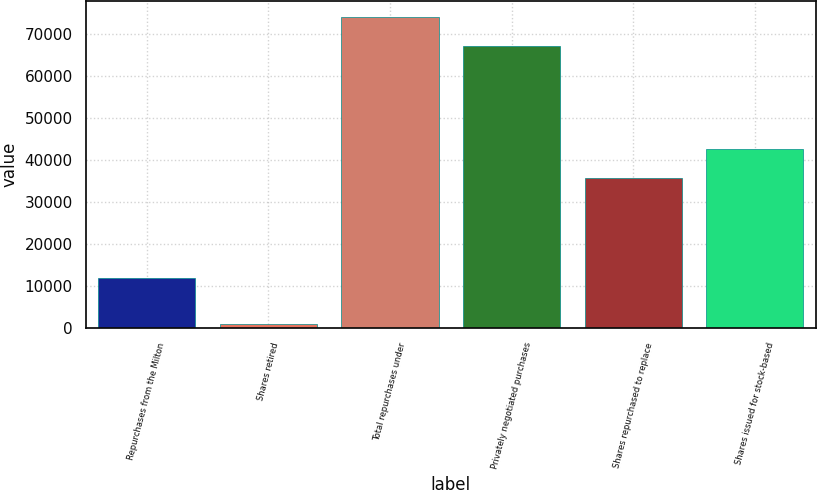Convert chart. <chart><loc_0><loc_0><loc_500><loc_500><bar_chart><fcel>Repurchases from the Milton<fcel>Shares retired<fcel>Total repurchases under<fcel>Privately negotiated purchases<fcel>Shares repurchased to replace<fcel>Shares issued for stock-based<nl><fcel>11918<fcel>1056<fcel>74196.5<fcel>67282<fcel>35740<fcel>42654.5<nl></chart> 